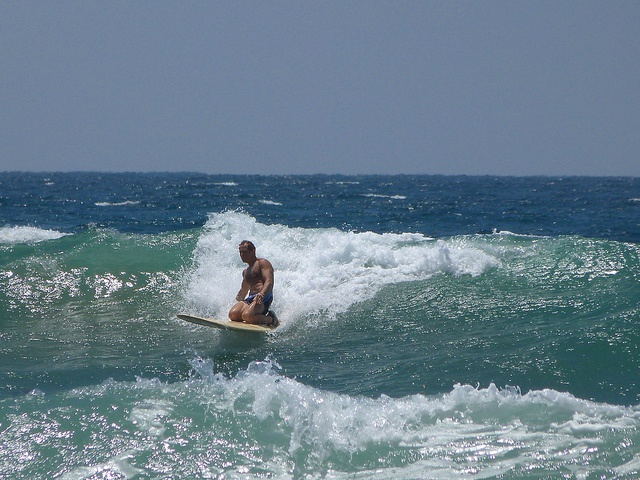Describe the objects in this image and their specific colors. I can see people in gray and black tones and surfboard in gray, darkgray, black, and tan tones in this image. 